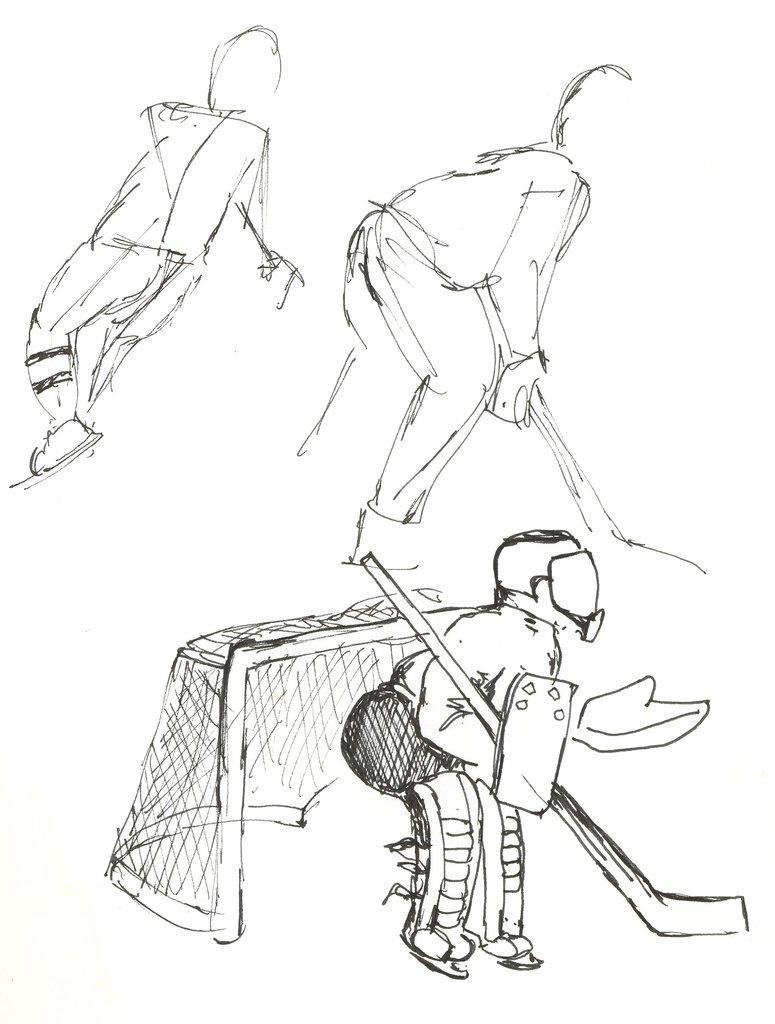Describe this image in one or two sentences. In this image we can see the art of three persons with hockey sticks and one net. There is a white background. 